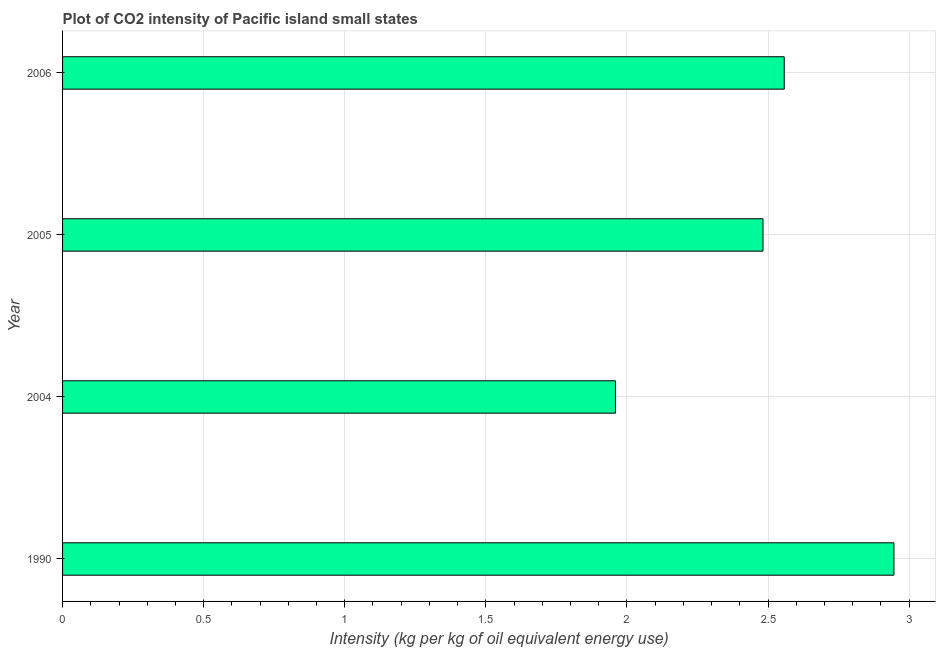What is the title of the graph?
Provide a short and direct response. Plot of CO2 intensity of Pacific island small states. What is the label or title of the X-axis?
Keep it short and to the point. Intensity (kg per kg of oil equivalent energy use). What is the co2 intensity in 2006?
Keep it short and to the point. 2.56. Across all years, what is the maximum co2 intensity?
Offer a terse response. 2.95. Across all years, what is the minimum co2 intensity?
Offer a very short reply. 1.96. In which year was the co2 intensity maximum?
Keep it short and to the point. 1990. What is the sum of the co2 intensity?
Your response must be concise. 9.94. What is the difference between the co2 intensity in 1990 and 2005?
Provide a short and direct response. 0.46. What is the average co2 intensity per year?
Keep it short and to the point. 2.49. What is the median co2 intensity?
Give a very brief answer. 2.52. What is the ratio of the co2 intensity in 2005 to that in 2006?
Keep it short and to the point. 0.97. Is the co2 intensity in 1990 less than that in 2005?
Your answer should be very brief. No. What is the difference between the highest and the second highest co2 intensity?
Give a very brief answer. 0.39. What is the difference between the highest and the lowest co2 intensity?
Keep it short and to the point. 0.99. In how many years, is the co2 intensity greater than the average co2 intensity taken over all years?
Ensure brevity in your answer.  2. How many bars are there?
Give a very brief answer. 4. How many years are there in the graph?
Your answer should be compact. 4. Are the values on the major ticks of X-axis written in scientific E-notation?
Offer a terse response. No. What is the Intensity (kg per kg of oil equivalent energy use) of 1990?
Your response must be concise. 2.95. What is the Intensity (kg per kg of oil equivalent energy use) in 2004?
Keep it short and to the point. 1.96. What is the Intensity (kg per kg of oil equivalent energy use) in 2005?
Give a very brief answer. 2.48. What is the Intensity (kg per kg of oil equivalent energy use) in 2006?
Provide a short and direct response. 2.56. What is the difference between the Intensity (kg per kg of oil equivalent energy use) in 1990 and 2004?
Your answer should be very brief. 0.99. What is the difference between the Intensity (kg per kg of oil equivalent energy use) in 1990 and 2005?
Your response must be concise. 0.46. What is the difference between the Intensity (kg per kg of oil equivalent energy use) in 1990 and 2006?
Provide a short and direct response. 0.39. What is the difference between the Intensity (kg per kg of oil equivalent energy use) in 2004 and 2005?
Provide a succinct answer. -0.52. What is the difference between the Intensity (kg per kg of oil equivalent energy use) in 2004 and 2006?
Offer a very short reply. -0.6. What is the difference between the Intensity (kg per kg of oil equivalent energy use) in 2005 and 2006?
Provide a succinct answer. -0.08. What is the ratio of the Intensity (kg per kg of oil equivalent energy use) in 1990 to that in 2004?
Provide a succinct answer. 1.5. What is the ratio of the Intensity (kg per kg of oil equivalent energy use) in 1990 to that in 2005?
Provide a short and direct response. 1.19. What is the ratio of the Intensity (kg per kg of oil equivalent energy use) in 1990 to that in 2006?
Provide a succinct answer. 1.15. What is the ratio of the Intensity (kg per kg of oil equivalent energy use) in 2004 to that in 2005?
Keep it short and to the point. 0.79. What is the ratio of the Intensity (kg per kg of oil equivalent energy use) in 2004 to that in 2006?
Provide a short and direct response. 0.77. What is the ratio of the Intensity (kg per kg of oil equivalent energy use) in 2005 to that in 2006?
Give a very brief answer. 0.97. 